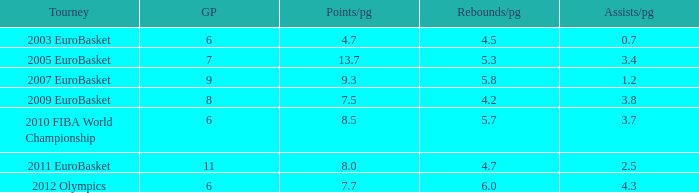How many points per game have the tournament 2005 eurobasket? 13.7. 